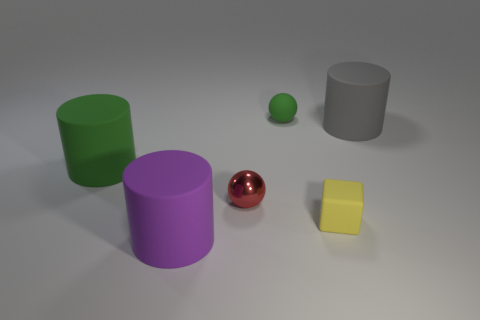Are there any other things that are made of the same material as the tiny red thing?
Make the answer very short. No. Is there anything else that has the same shape as the yellow rubber object?
Make the answer very short. No. There is a green thing that is on the left side of the tiny matte sphere; how many small matte objects are in front of it?
Keep it short and to the point. 1. Is there a large cyan metal thing of the same shape as the purple matte object?
Provide a succinct answer. No. There is a small thing that is in front of the red thing; does it have the same shape as the green object that is behind the big green rubber thing?
Offer a terse response. No. What number of objects are either big gray metallic blocks or metal things?
Provide a short and direct response. 1. The green thing that is the same shape as the gray rubber object is what size?
Offer a terse response. Large. Is the number of red metallic objects that are to the left of the purple matte cylinder greater than the number of gray cylinders?
Your response must be concise. No. Do the large purple thing and the small red thing have the same material?
Keep it short and to the point. No. How many things are large matte cylinders that are in front of the yellow block or small yellow rubber things that are to the right of the small matte ball?
Keep it short and to the point. 2. 